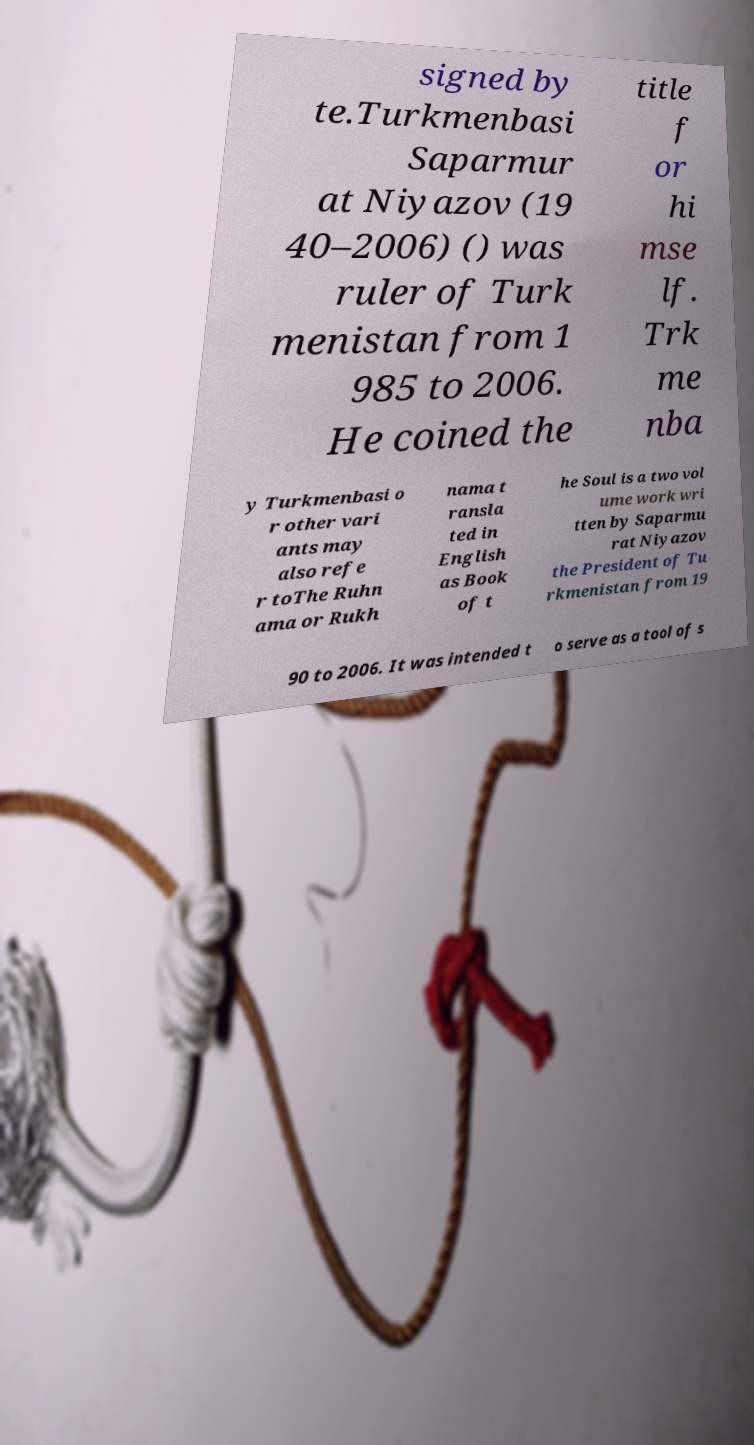Please identify and transcribe the text found in this image. signed by te.Turkmenbasi Saparmur at Niyazov (19 40–2006) () was ruler of Turk menistan from 1 985 to 2006. He coined the title f or hi mse lf. Trk me nba y Turkmenbasi o r other vari ants may also refe r toThe Ruhn ama or Rukh nama t ransla ted in English as Book of t he Soul is a two vol ume work wri tten by Saparmu rat Niyazov the President of Tu rkmenistan from 19 90 to 2006. It was intended t o serve as a tool of s 